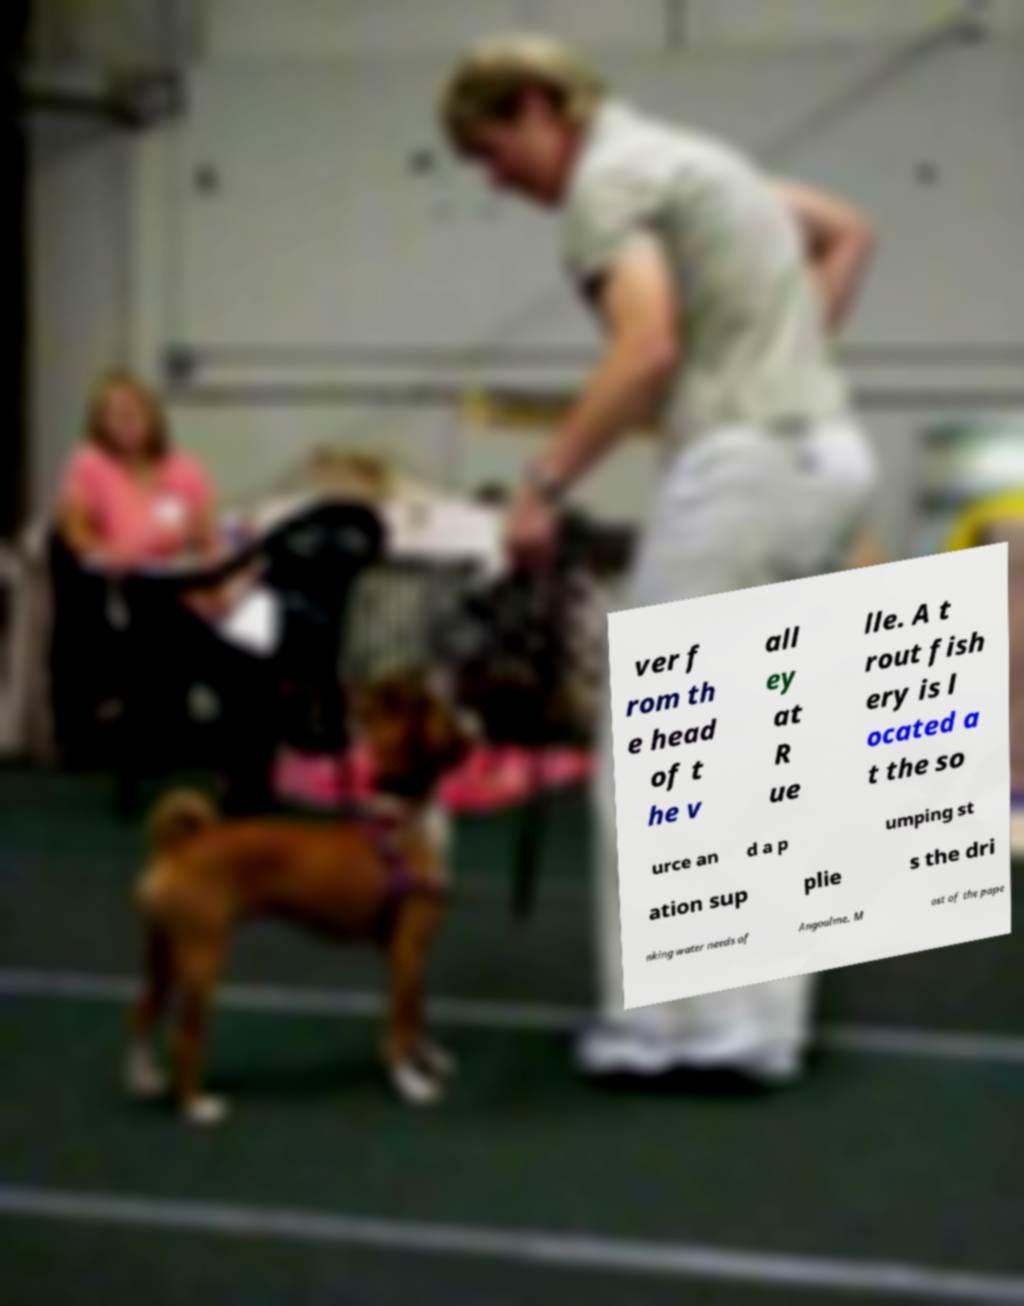Can you accurately transcribe the text from the provided image for me? ver f rom th e head of t he v all ey at R ue lle. A t rout fish ery is l ocated a t the so urce an d a p umping st ation sup plie s the dri nking water needs of Angoulme. M ost of the pape 